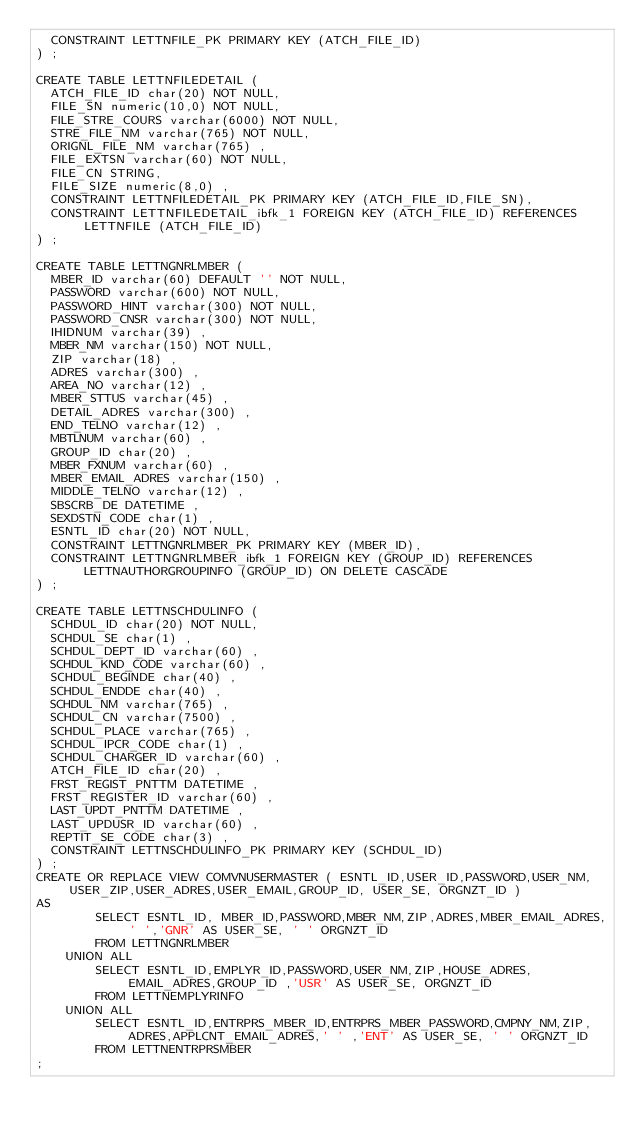<code> <loc_0><loc_0><loc_500><loc_500><_SQL_>  CONSTRAINT LETTNFILE_PK PRIMARY KEY (ATCH_FILE_ID)
) ;

CREATE TABLE LETTNFILEDETAIL (
  ATCH_FILE_ID char(20) NOT NULL,
  FILE_SN numeric(10,0) NOT NULL,
  FILE_STRE_COURS varchar(6000) NOT NULL,
  STRE_FILE_NM varchar(765) NOT NULL,
  ORIGNL_FILE_NM varchar(765) ,
  FILE_EXTSN varchar(60) NOT NULL,
  FILE_CN STRING,
  FILE_SIZE numeric(8,0) ,
  CONSTRAINT LETTNFILEDETAIL_PK PRIMARY KEY (ATCH_FILE_ID,FILE_SN),
  CONSTRAINT LETTNFILEDETAIL_ibfk_1 FOREIGN KEY (ATCH_FILE_ID) REFERENCES LETTNFILE (ATCH_FILE_ID)
) ;

CREATE TABLE LETTNGNRLMBER (
  MBER_ID varchar(60) DEFAULT '' NOT NULL,
  PASSWORD varchar(600) NOT NULL,
  PASSWORD_HINT varchar(300) NOT NULL,
  PASSWORD_CNSR varchar(300) NOT NULL,
  IHIDNUM varchar(39) ,
  MBER_NM varchar(150) NOT NULL,
  ZIP varchar(18) ,
  ADRES varchar(300) ,
  AREA_NO varchar(12) ,
  MBER_STTUS varchar(45) ,
  DETAIL_ADRES varchar(300) ,
  END_TELNO varchar(12) ,
  MBTLNUM varchar(60) ,
  GROUP_ID char(20) ,
  MBER_FXNUM varchar(60) ,
  MBER_EMAIL_ADRES varchar(150) ,
  MIDDLE_TELNO varchar(12) ,
  SBSCRB_DE DATETIME ,
  SEXDSTN_CODE char(1) ,
  ESNTL_ID char(20) NOT NULL,
  CONSTRAINT LETTNGNRLMBER_PK PRIMARY KEY (MBER_ID),
  CONSTRAINT LETTNGNRLMBER_ibfk_1 FOREIGN KEY (GROUP_ID) REFERENCES LETTNAUTHORGROUPINFO (GROUP_ID) ON DELETE CASCADE
) ;

CREATE TABLE LETTNSCHDULINFO (
  SCHDUL_ID char(20) NOT NULL,
  SCHDUL_SE char(1) ,
  SCHDUL_DEPT_ID varchar(60) ,
  SCHDUL_KND_CODE varchar(60) ,
  SCHDUL_BEGINDE char(40) ,
  SCHDUL_ENDDE char(40) ,
  SCHDUL_NM varchar(765) ,
  SCHDUL_CN varchar(7500) ,
  SCHDUL_PLACE varchar(765) ,
  SCHDUL_IPCR_CODE char(1) ,
  SCHDUL_CHARGER_ID varchar(60) ,
  ATCH_FILE_ID char(20) ,
  FRST_REGIST_PNTTM DATETIME ,
  FRST_REGISTER_ID varchar(60) ,
  LAST_UPDT_PNTTM DATETIME ,
  LAST_UPDUSR_ID varchar(60) ,
  REPTIT_SE_CODE char(3) ,
  CONSTRAINT LETTNSCHDULINFO_PK PRIMARY KEY (SCHDUL_ID)
) ;
CREATE OR REPLACE VIEW COMVNUSERMASTER ( ESNTL_ID,USER_ID,PASSWORD,USER_NM,USER_ZIP,USER_ADRES,USER_EMAIL,GROUP_ID, USER_SE, ORGNZT_ID ) 
AS  
        SELECT ESNTL_ID, MBER_ID,PASSWORD,MBER_NM,ZIP,ADRES,MBER_EMAIL_ADRES,' ','GNR' AS USER_SE, ' ' ORGNZT_ID
        FROM LETTNGNRLMBER
    UNION ALL
        SELECT ESNTL_ID,EMPLYR_ID,PASSWORD,USER_NM,ZIP,HOUSE_ADRES,EMAIL_ADRES,GROUP_ID ,'USR' AS USER_SE, ORGNZT_ID
        FROM LETTNEMPLYRINFO
    UNION ALL
        SELECT ESNTL_ID,ENTRPRS_MBER_ID,ENTRPRS_MBER_PASSWORD,CMPNY_NM,ZIP,ADRES,APPLCNT_EMAIL_ADRES,' ' ,'ENT' AS USER_SE, ' ' ORGNZT_ID
        FROM LETTNENTRPRSMBER 
;</code> 